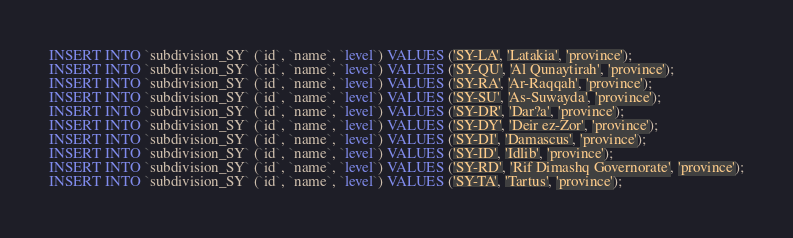<code> <loc_0><loc_0><loc_500><loc_500><_SQL_>INSERT INTO `subdivision_SY` (`id`, `name`, `level`) VALUES ('SY-LA', 'Latakia', 'province');
INSERT INTO `subdivision_SY` (`id`, `name`, `level`) VALUES ('SY-QU', 'Al Qunaytirah', 'province');
INSERT INTO `subdivision_SY` (`id`, `name`, `level`) VALUES ('SY-RA', 'Ar-Raqqah', 'province');
INSERT INTO `subdivision_SY` (`id`, `name`, `level`) VALUES ('SY-SU', 'As-Suwayda', 'province');
INSERT INTO `subdivision_SY` (`id`, `name`, `level`) VALUES ('SY-DR', 'Dar?a', 'province');
INSERT INTO `subdivision_SY` (`id`, `name`, `level`) VALUES ('SY-DY', 'Deir ez-Zor', 'province');
INSERT INTO `subdivision_SY` (`id`, `name`, `level`) VALUES ('SY-DI', 'Damascus', 'province');
INSERT INTO `subdivision_SY` (`id`, `name`, `level`) VALUES ('SY-ID', 'Idlib', 'province');
INSERT INTO `subdivision_SY` (`id`, `name`, `level`) VALUES ('SY-RD', 'Rif Dimashq Governorate', 'province');
INSERT INTO `subdivision_SY` (`id`, `name`, `level`) VALUES ('SY-TA', 'Tartus', 'province');
</code> 